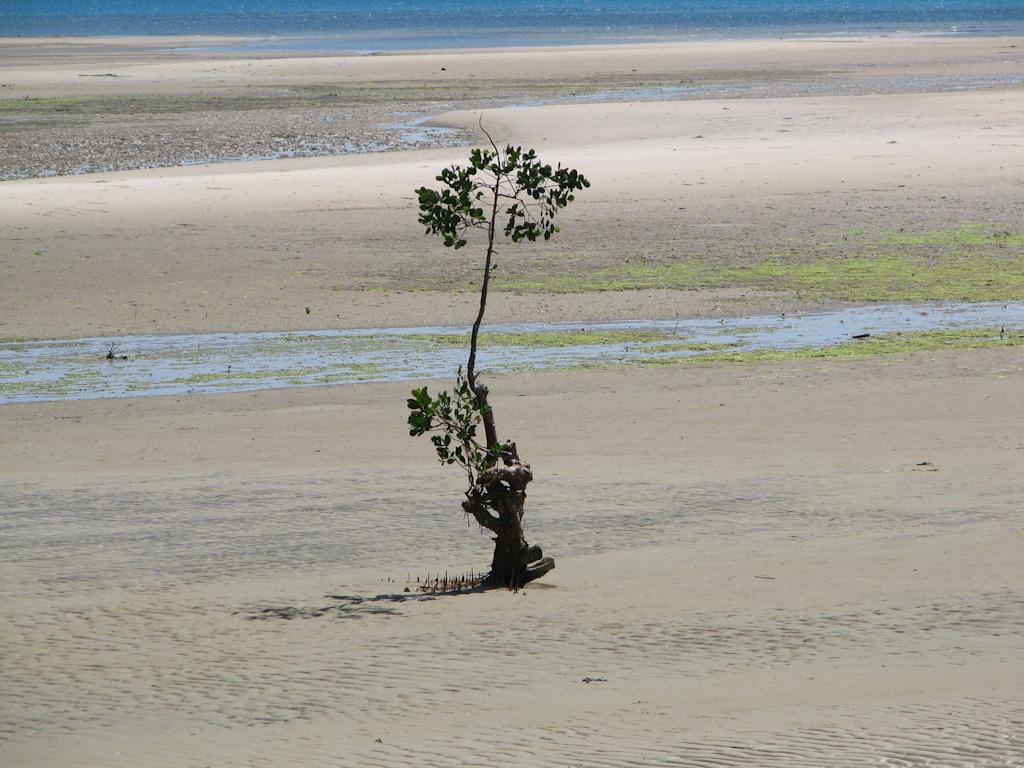Please provide a concise description of this image. Here in this picture we can see a plant present on the ground and we can see some part of ground is covered with grass and we can also see water present in the far. 